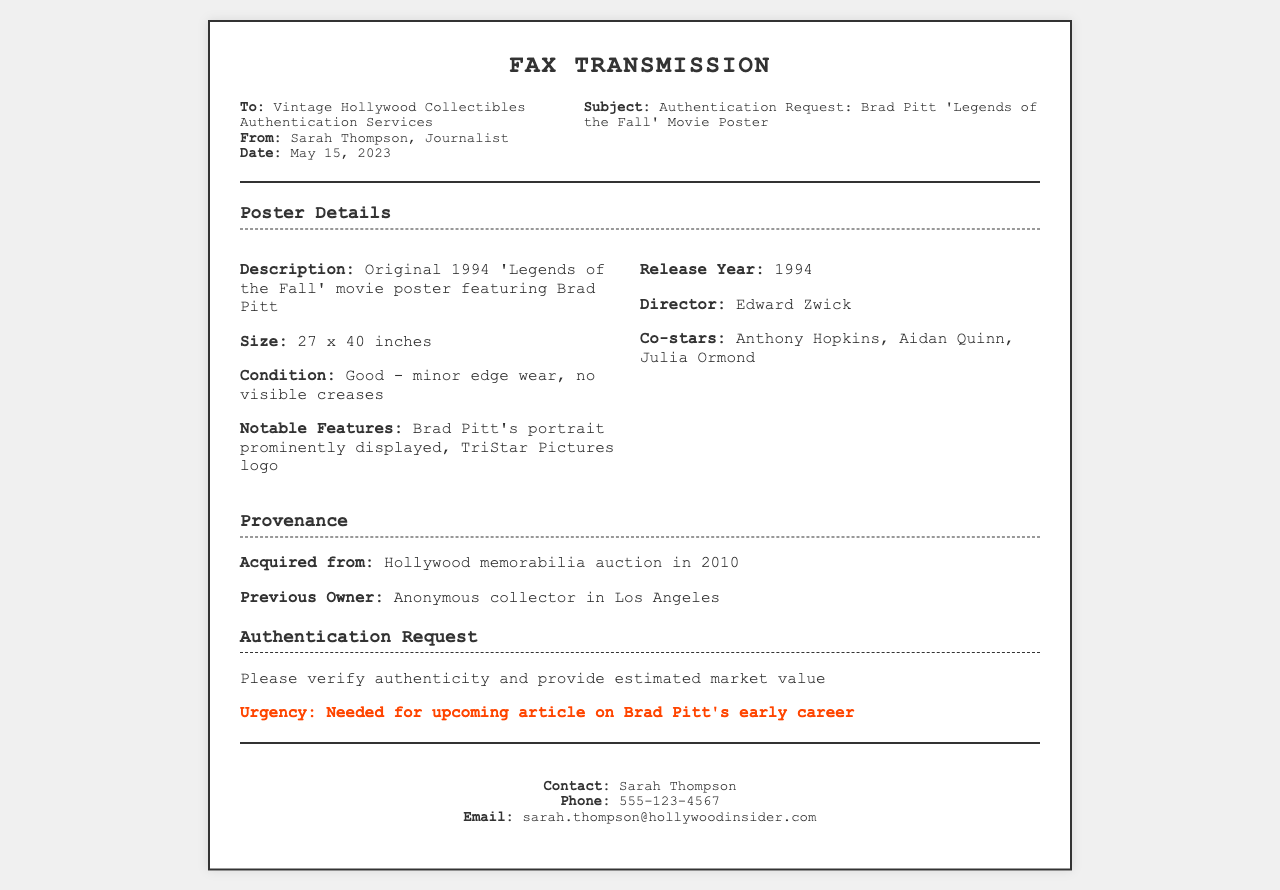What is the title of the movie featured on the poster? The title is specified in the subject of the fax, referring to the Brad Pitt movie.
Answer: Legends of the Fall Who is the director of the movie? The director's name is mentioned in the poster details section.
Answer: Edward Zwick What is the size of the poster? The dimensions of the poster are provided in the details section.
Answer: 27 x 40 inches When was the poster acquired? The acquisition date is stated in the provenance section of the document.
Answer: 2010 What condition is the poster in? The condition of the poster is described in the poster details section.
Answer: Good - minor edge wear, no visible creases Who are the co-stars listed for the movie? The co-stars are mentioned next to the director's name in the poster information.
Answer: Anthony Hopkins, Aidan Quinn, Julia Ormond What is the urgency of the authentication request? The urgency is emphasized in the authentication request section of the fax.
Answer: Needed for upcoming article on Brad Pitt's early career Who is the sender of the fax? The sender's name is provided in the header information of the fax.
Answer: Sarah Thompson What type of document is this? The document is introduced by its title at the top of the fax.
Answer: Fax Transmission 